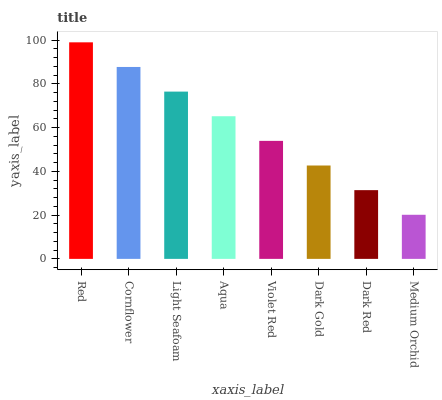Is Medium Orchid the minimum?
Answer yes or no. Yes. Is Red the maximum?
Answer yes or no. Yes. Is Cornflower the minimum?
Answer yes or no. No. Is Cornflower the maximum?
Answer yes or no. No. Is Red greater than Cornflower?
Answer yes or no. Yes. Is Cornflower less than Red?
Answer yes or no. Yes. Is Cornflower greater than Red?
Answer yes or no. No. Is Red less than Cornflower?
Answer yes or no. No. Is Aqua the high median?
Answer yes or no. Yes. Is Violet Red the low median?
Answer yes or no. Yes. Is Cornflower the high median?
Answer yes or no. No. Is Medium Orchid the low median?
Answer yes or no. No. 